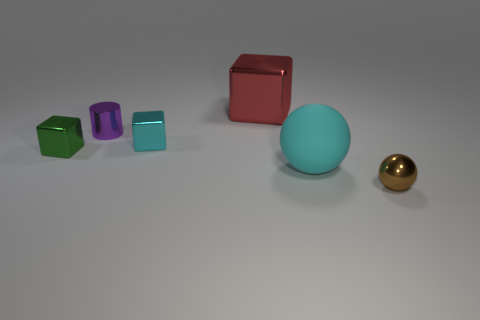Subtract all spheres. How many objects are left? 4 Add 1 brown objects. How many objects exist? 7 Subtract all small metallic blocks. How many blocks are left? 1 Add 5 spheres. How many spheres are left? 7 Add 5 big red metallic cubes. How many big red metallic cubes exist? 6 Subtract all green cubes. How many cubes are left? 2 Subtract 0 green cylinders. How many objects are left? 6 Subtract 1 spheres. How many spheres are left? 1 Subtract all green cylinders. Subtract all cyan spheres. How many cylinders are left? 1 Subtract all blue cubes. How many brown balls are left? 1 